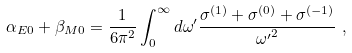Convert formula to latex. <formula><loc_0><loc_0><loc_500><loc_500>\alpha _ { E 0 } + \beta _ { M 0 } = \frac { 1 } { 6 \pi ^ { 2 } } \int ^ { \infty } _ { 0 } { d \omega ^ { \prime } } \frac { \sigma ^ { ( 1 ) } + \sigma ^ { ( 0 ) } + \sigma ^ { ( - 1 ) } } { { \omega ^ { \prime } } ^ { 2 } } \ ,</formula> 